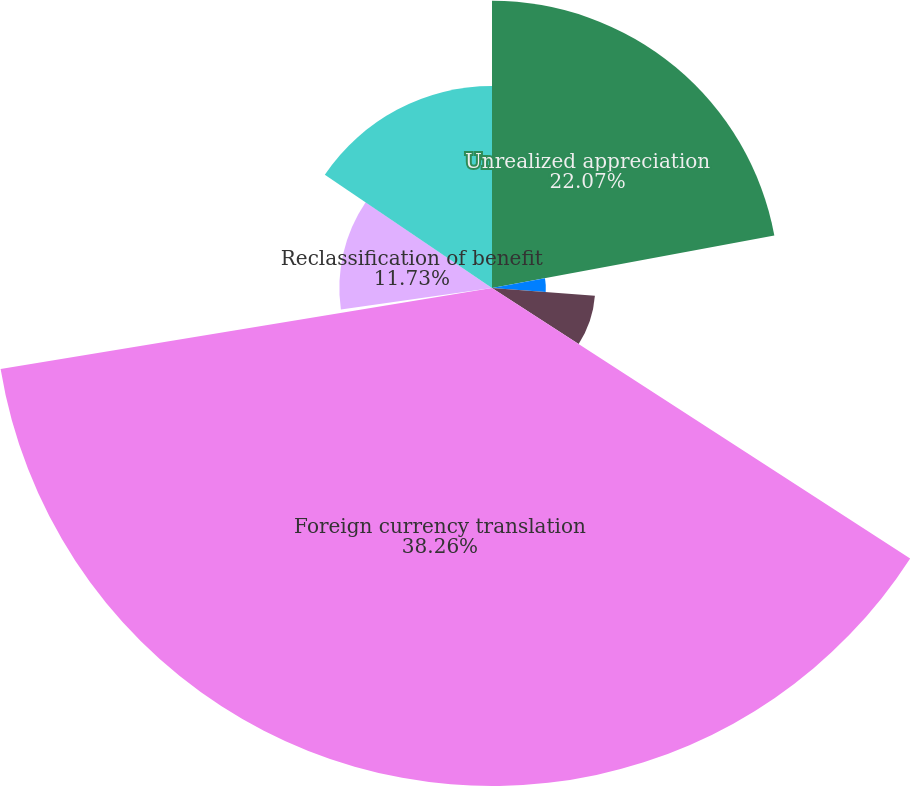Convert chart. <chart><loc_0><loc_0><loc_500><loc_500><pie_chart><fcel>Unrealized appreciation<fcel>URA(D) on securities - OTTI<fcel>Reclassification of net<fcel>Foreign currency translation<fcel>Benefit plan actuarial net<fcel>Reclassification of benefit<fcel>Total other comprehensive<nl><fcel>22.07%<fcel>4.14%<fcel>7.93%<fcel>38.27%<fcel>0.35%<fcel>11.73%<fcel>15.52%<nl></chart> 